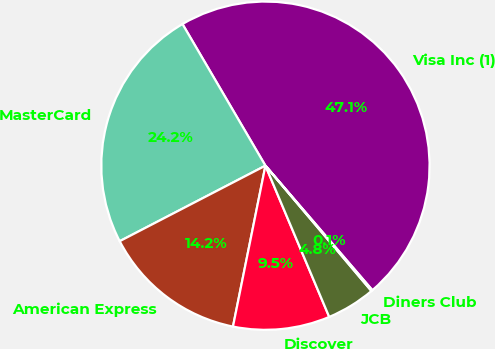Convert chart to OTSL. <chart><loc_0><loc_0><loc_500><loc_500><pie_chart><fcel>Visa Inc (1)<fcel>MasterCard<fcel>American Express<fcel>Discover<fcel>JCB<fcel>Diners Club<nl><fcel>47.13%<fcel>24.17%<fcel>14.22%<fcel>9.52%<fcel>4.82%<fcel>0.12%<nl></chart> 